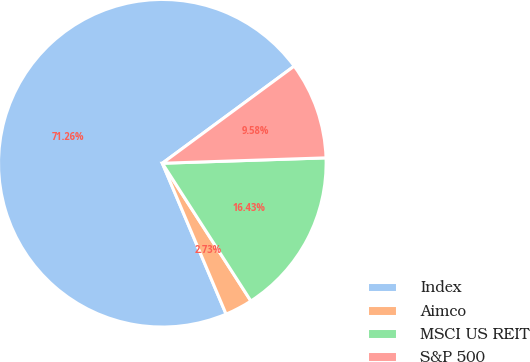Convert chart to OTSL. <chart><loc_0><loc_0><loc_500><loc_500><pie_chart><fcel>Index<fcel>Aimco<fcel>MSCI US REIT<fcel>S&P 500<nl><fcel>71.26%<fcel>2.73%<fcel>16.43%<fcel>9.58%<nl></chart> 